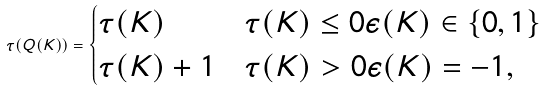Convert formula to latex. <formula><loc_0><loc_0><loc_500><loc_500>\tau ( Q ( K ) ) = \begin{cases} \tau ( K ) & \tau ( K ) \leq 0 \epsilon ( K ) \in \{ 0 , 1 \} \\ \tau ( K ) + 1 & \tau ( K ) > 0 \epsilon ( K ) = - 1 , \end{cases}</formula> 